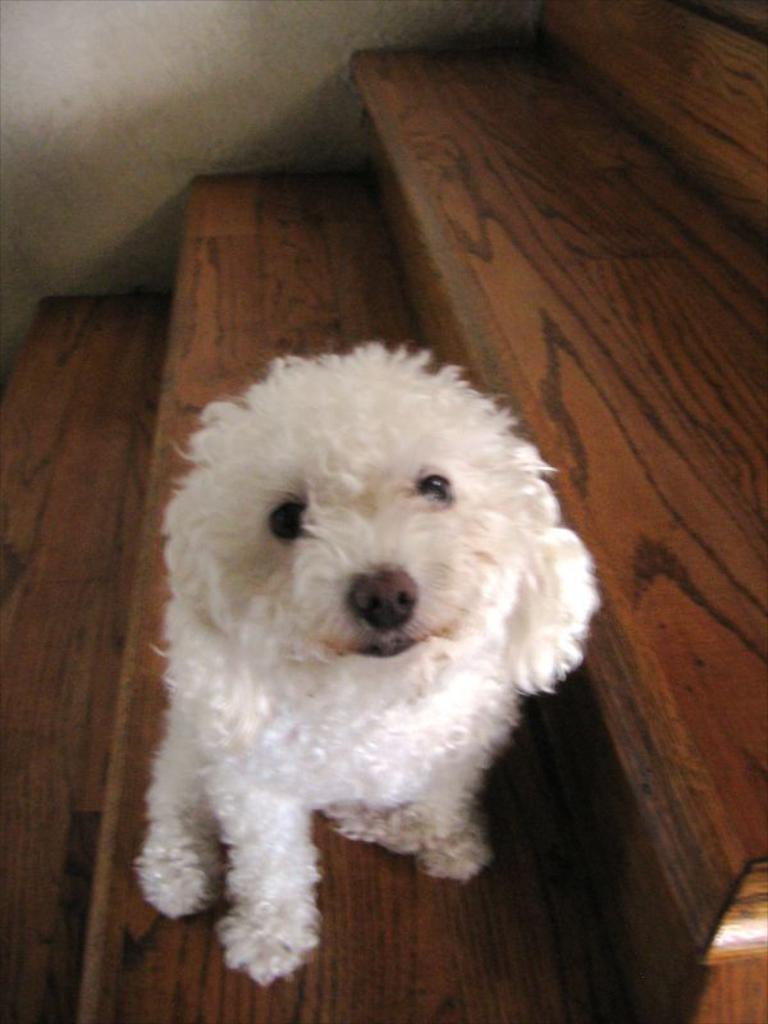Could you give a brief overview of what you see in this image? In this image we can see a white color dog on the wooden stairs. 